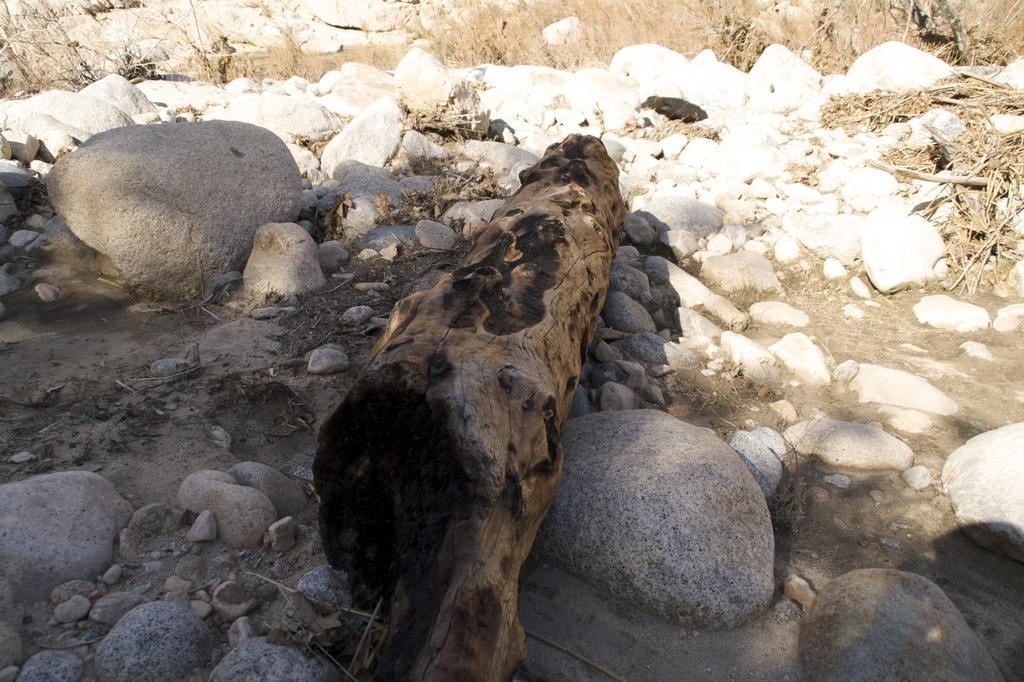In one or two sentences, can you explain what this image depicts? In this image I can see there is a trunk of a tree in between the rocks and there is some grass in the background. 